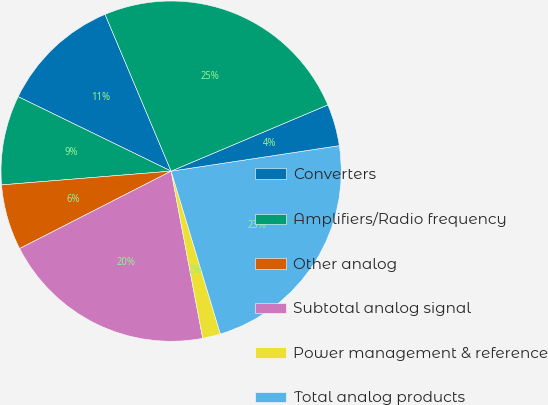Convert chart. <chart><loc_0><loc_0><loc_500><loc_500><pie_chart><fcel>Converters<fcel>Amplifiers/Radio frequency<fcel>Other analog<fcel>Subtotal analog signal<fcel>Power management & reference<fcel>Total analog products<fcel>Digital signal processing<fcel>Total Revenue<nl><fcel>11.44%<fcel>8.5%<fcel>6.23%<fcel>20.45%<fcel>1.7%<fcel>22.72%<fcel>3.97%<fcel>24.98%<nl></chart> 